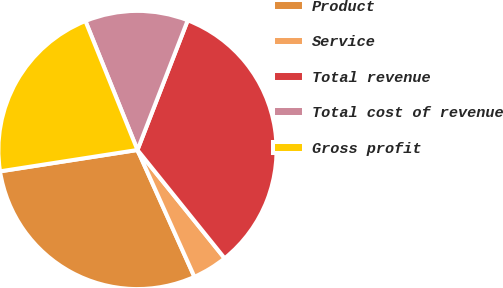Convert chart. <chart><loc_0><loc_0><loc_500><loc_500><pie_chart><fcel>Product<fcel>Service<fcel>Total revenue<fcel>Total cost of revenue<fcel>Gross profit<nl><fcel>29.26%<fcel>4.07%<fcel>33.33%<fcel>11.99%<fcel>21.35%<nl></chart> 